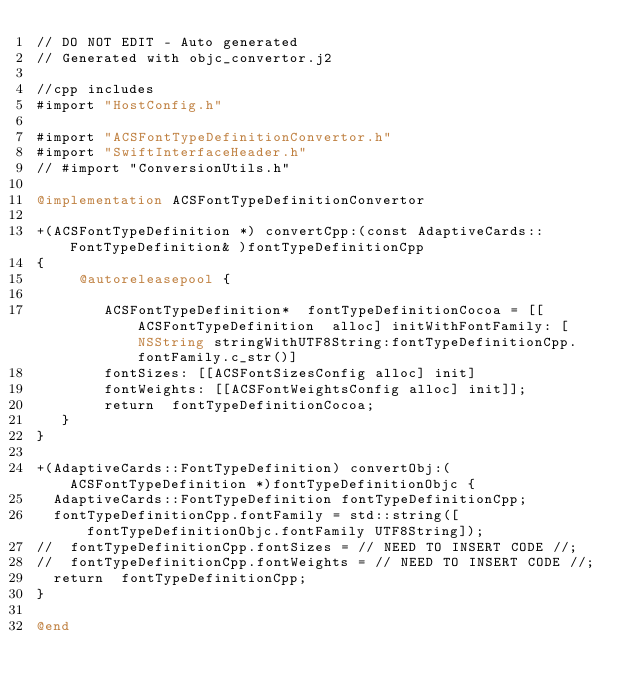<code> <loc_0><loc_0><loc_500><loc_500><_ObjectiveC_>// DO NOT EDIT - Auto generated
// Generated with objc_convertor.j2

//cpp includes 
#import "HostConfig.h"

#import "ACSFontTypeDefinitionConvertor.h"
#import "SwiftInterfaceHeader.h"
// #import "ConversionUtils.h"

@implementation ACSFontTypeDefinitionConvertor 

+(ACSFontTypeDefinition *) convertCpp:(const AdaptiveCards::FontTypeDefinition& )fontTypeDefinitionCpp
{ 
     @autoreleasepool { 
 
        ACSFontTypeDefinition*  fontTypeDefinitionCocoa = [[ ACSFontTypeDefinition  alloc] initWithFontFamily: [NSString stringWithUTF8String:fontTypeDefinitionCpp.fontFamily.c_str()] 
        fontSizes: [[ACSFontSizesConfig alloc] init]
        fontWeights: [[ACSFontWeightsConfig alloc] init]];
        return  fontTypeDefinitionCocoa;
   }
}

+(AdaptiveCards::FontTypeDefinition) convertObj:(ACSFontTypeDefinition *)fontTypeDefinitionObjc {
  AdaptiveCards::FontTypeDefinition fontTypeDefinitionCpp;
  fontTypeDefinitionCpp.fontFamily = std::string([fontTypeDefinitionObjc.fontFamily UTF8String]);
//  fontTypeDefinitionCpp.fontSizes = // NEED TO INSERT CODE //;
//  fontTypeDefinitionCpp.fontWeights = // NEED TO INSERT CODE //;
  return  fontTypeDefinitionCpp;
}

@end 
</code> 